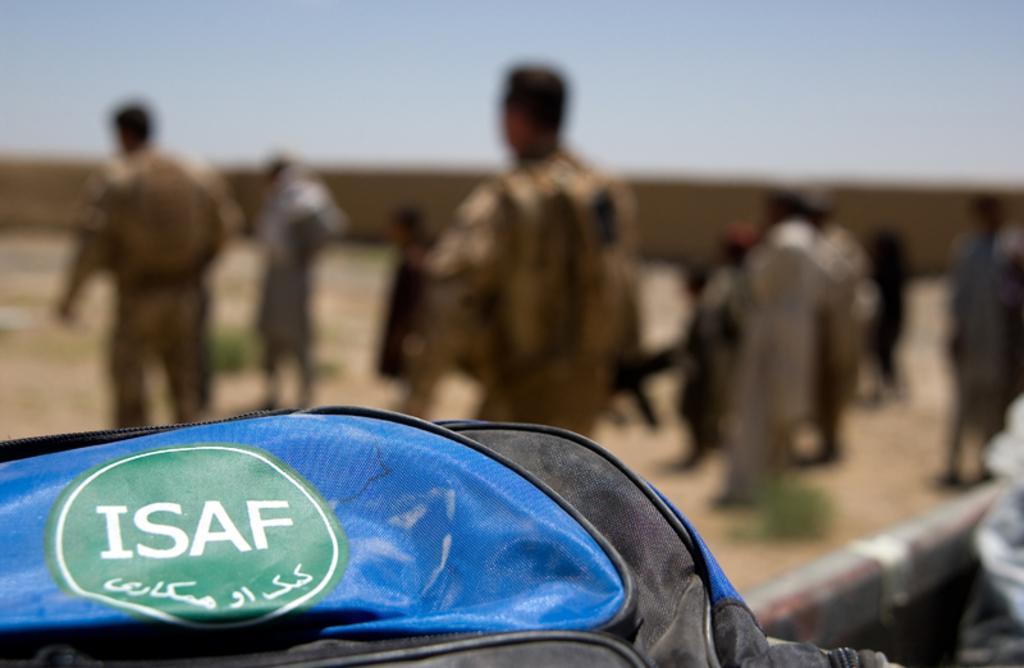In one or two sentences, can you explain what this image depicts? As we can see in the image in the front there is a blue color bag and few people here and there. The background is blurred. On the top there is sky. 